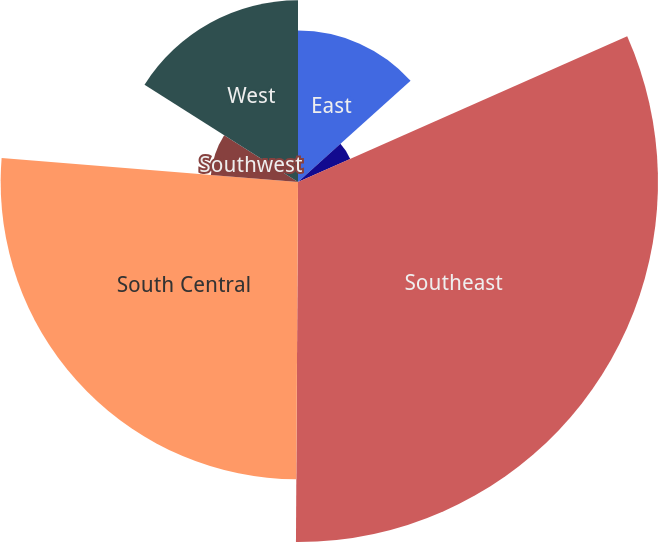Convert chart to OTSL. <chart><loc_0><loc_0><loc_500><loc_500><pie_chart><fcel>East<fcel>Midwest<fcel>Southeast<fcel>South Central<fcel>Southwest<fcel>West<nl><fcel>13.34%<fcel>5.03%<fcel>31.72%<fcel>26.2%<fcel>7.7%<fcel>16.01%<nl></chart> 